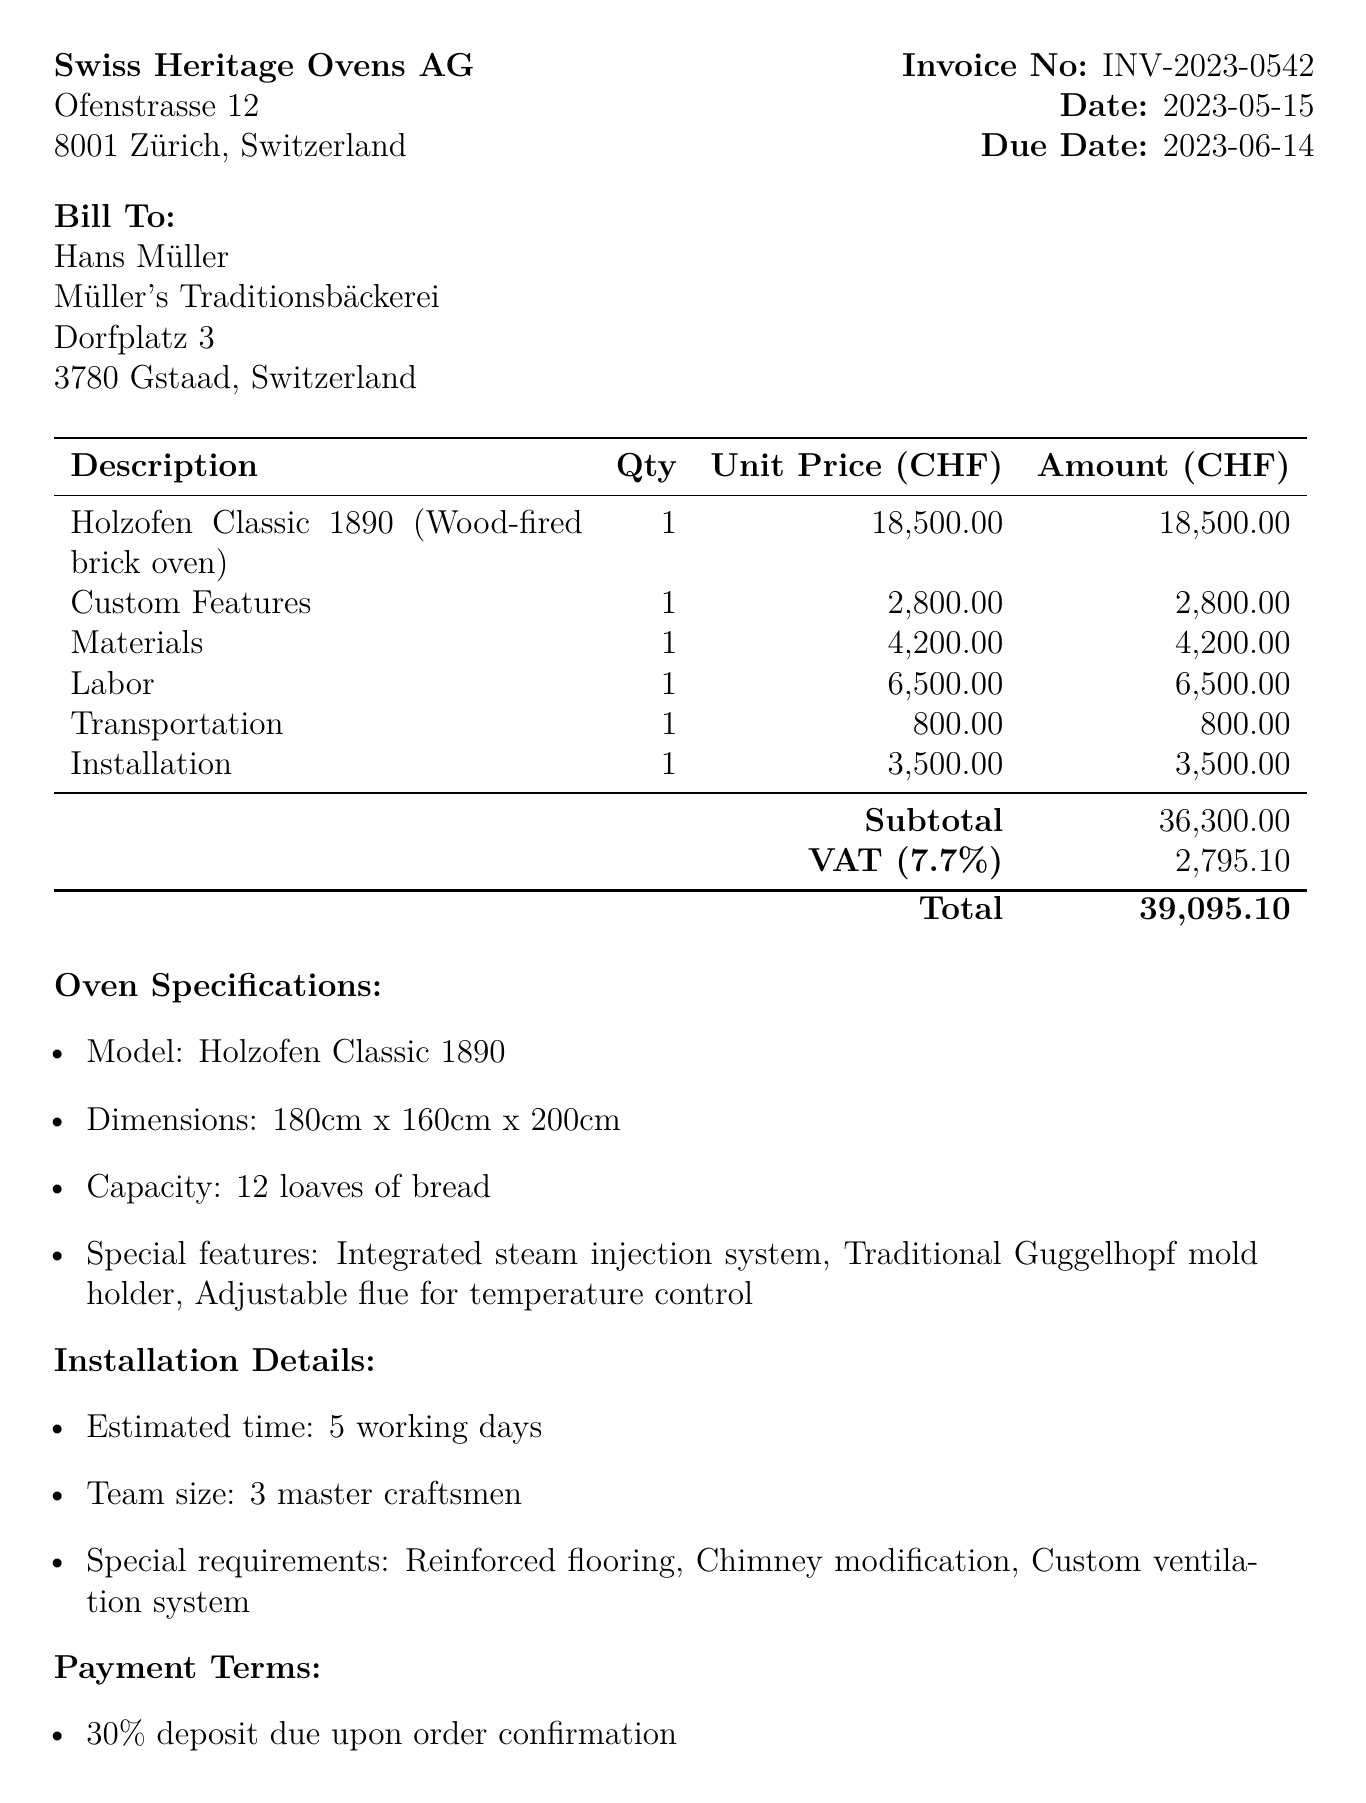What is the invoice number? The invoice number is listed clearly at the top of the document under "Invoice No".
Answer: INV-2023-0542 What is the total amount due? The total amount is calculated at the bottom of the document, after summing up the subtotal and VAT.
Answer: 39095.10 What is the model of the oven? The model of the oven is specified in the "Oven Specifications" section.
Answer: Holzofen Classic 1890 How many master craftsmen will be involved in the installation? The team size is mentioned in the "Installation Details" section.
Answer: 3 master craftsmen What percentage of the total amount is the deposit? The deposit percentage is indicated in the "Payment Terms" section.
Answer: 30% What time frame is estimated for the oven installation? The estimated installation time is detailed in the "Installation Details" section.
Answer: 5 working days Which company is issuing the invoice? The issuing company is presented in the top section of the document.
Answer: Swiss Heritage Ovens AG What are the special requirements for installation? The special requirements are listed under "Installation Details" in the document.
Answer: Reinforced flooring, Chimney modification, Custom ventilation system 